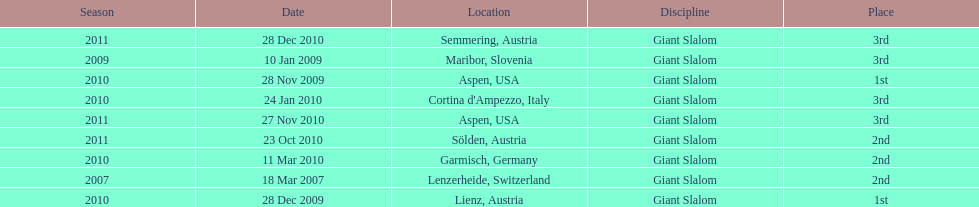What is the total number of her 2nd place finishes on the list? 3. 